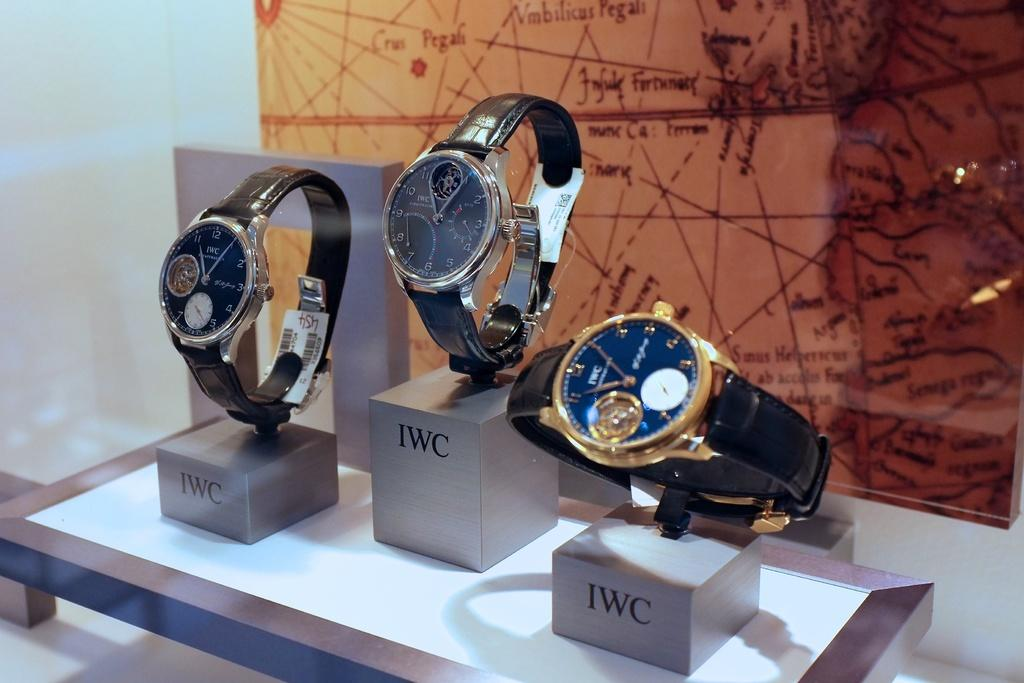What type of objects are featured in the image? There are watches in the image. What else can be seen in the background of the image? There is text in the background of the image. How many frogs are sitting on the floor in the image? There are no frogs present in the image, and the floor is not visible. 